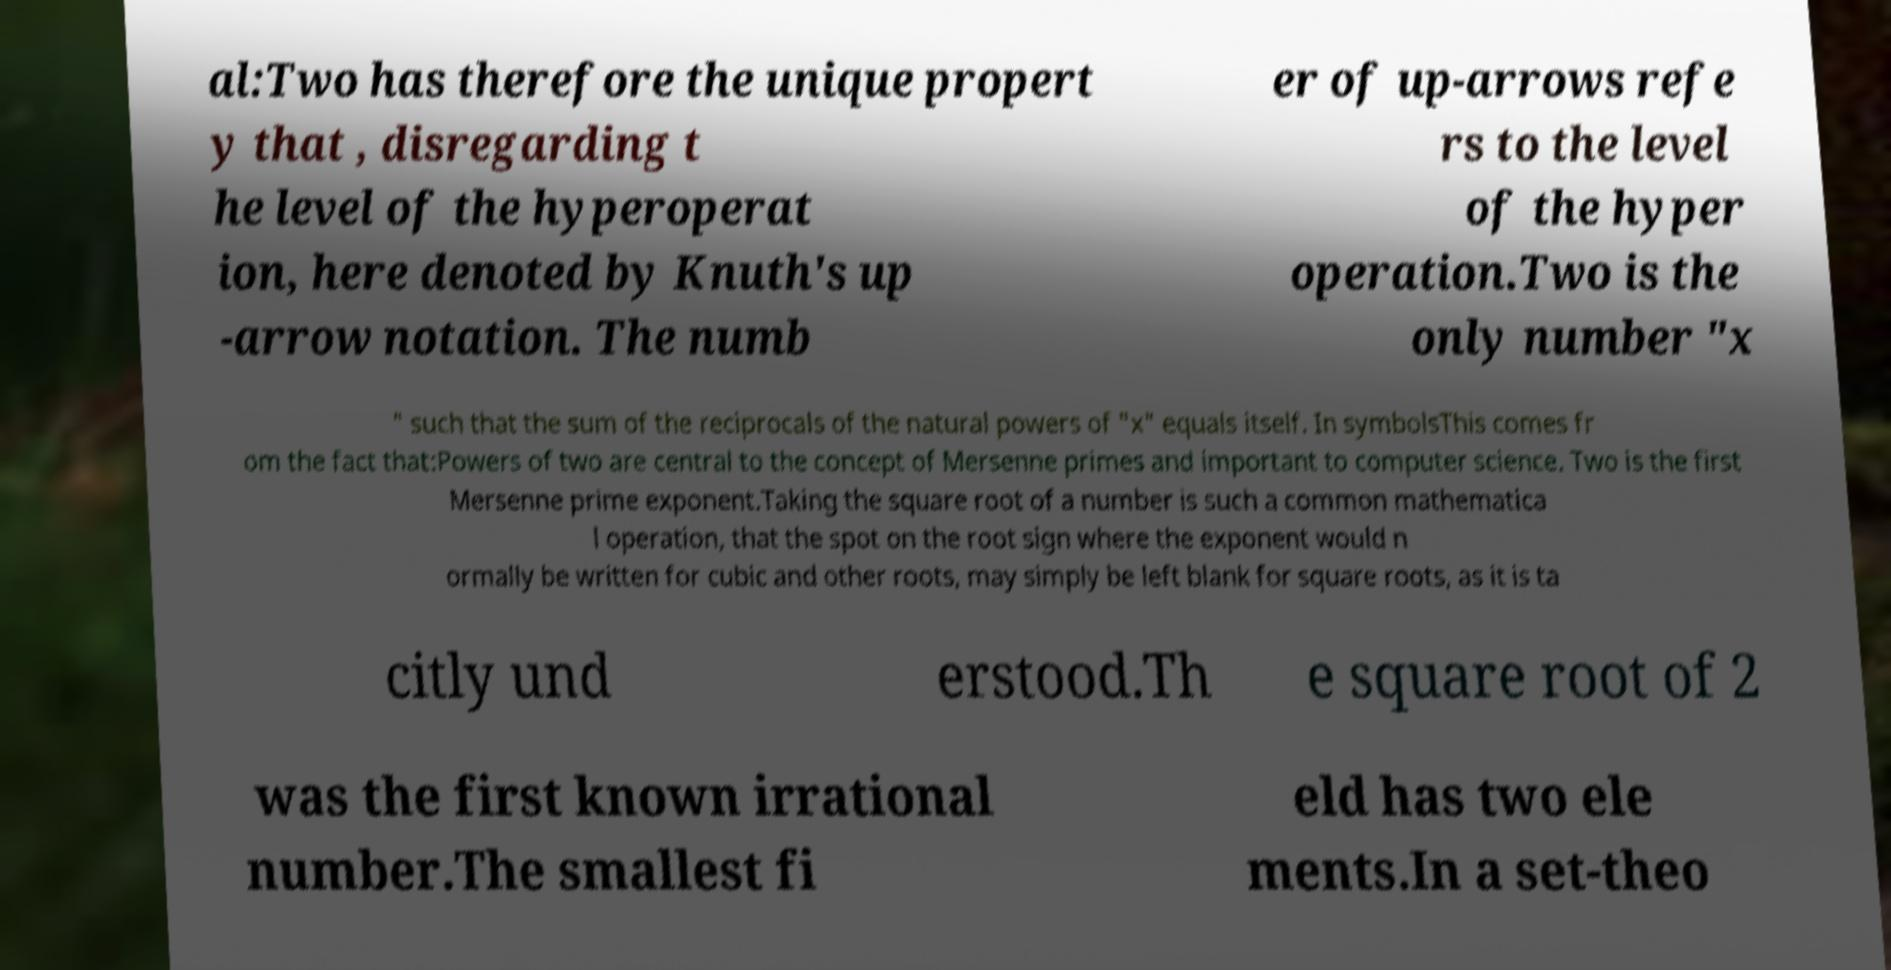For documentation purposes, I need the text within this image transcribed. Could you provide that? al:Two has therefore the unique propert y that , disregarding t he level of the hyperoperat ion, here denoted by Knuth's up -arrow notation. The numb er of up-arrows refe rs to the level of the hyper operation.Two is the only number "x " such that the sum of the reciprocals of the natural powers of "x" equals itself. In symbolsThis comes fr om the fact that:Powers of two are central to the concept of Mersenne primes and important to computer science. Two is the first Mersenne prime exponent.Taking the square root of a number is such a common mathematica l operation, that the spot on the root sign where the exponent would n ormally be written for cubic and other roots, may simply be left blank for square roots, as it is ta citly und erstood.Th e square root of 2 was the first known irrational number.The smallest fi eld has two ele ments.In a set-theo 